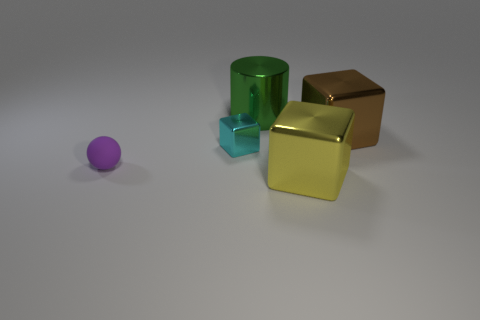Add 4 small purple shiny cylinders. How many objects exist? 9 Subtract all large cubes. How many cubes are left? 1 Subtract all yellow objects. Subtract all large metal cylinders. How many objects are left? 3 Add 1 brown metal objects. How many brown metal objects are left? 2 Add 3 brown metal objects. How many brown metal objects exist? 4 Subtract 0 cyan cylinders. How many objects are left? 5 Subtract all cylinders. How many objects are left? 4 Subtract all blue spheres. Subtract all cyan cylinders. How many spheres are left? 1 Subtract all brown cylinders. How many red spheres are left? 0 